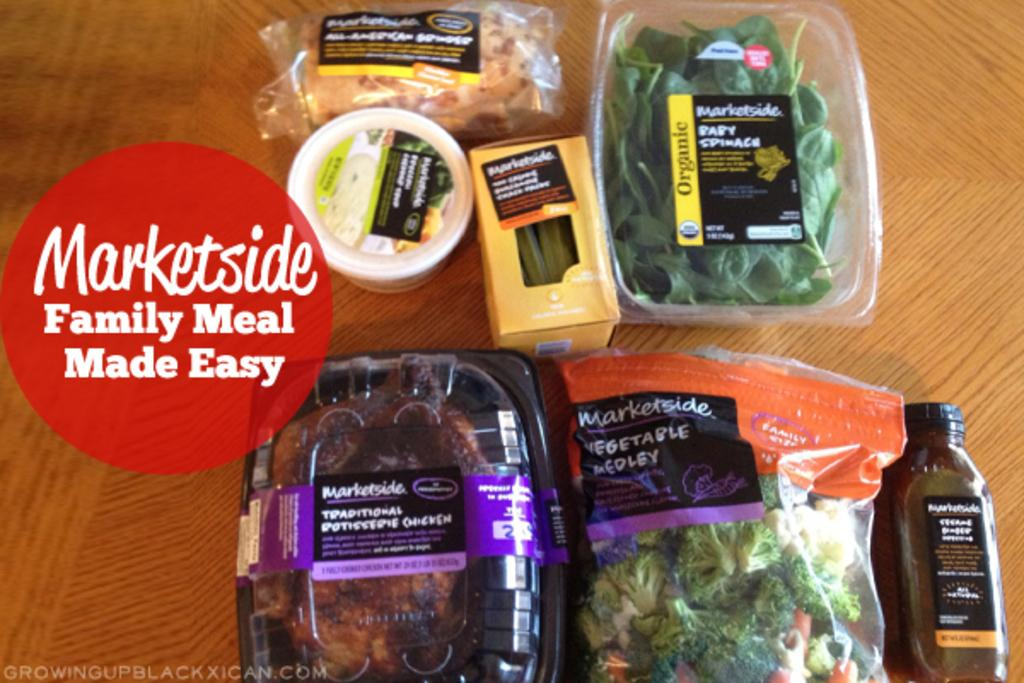<image>
Summarize the visual content of the image. A variety of food choices from the Marketside, it offers organic, traditional and medley family meals. 